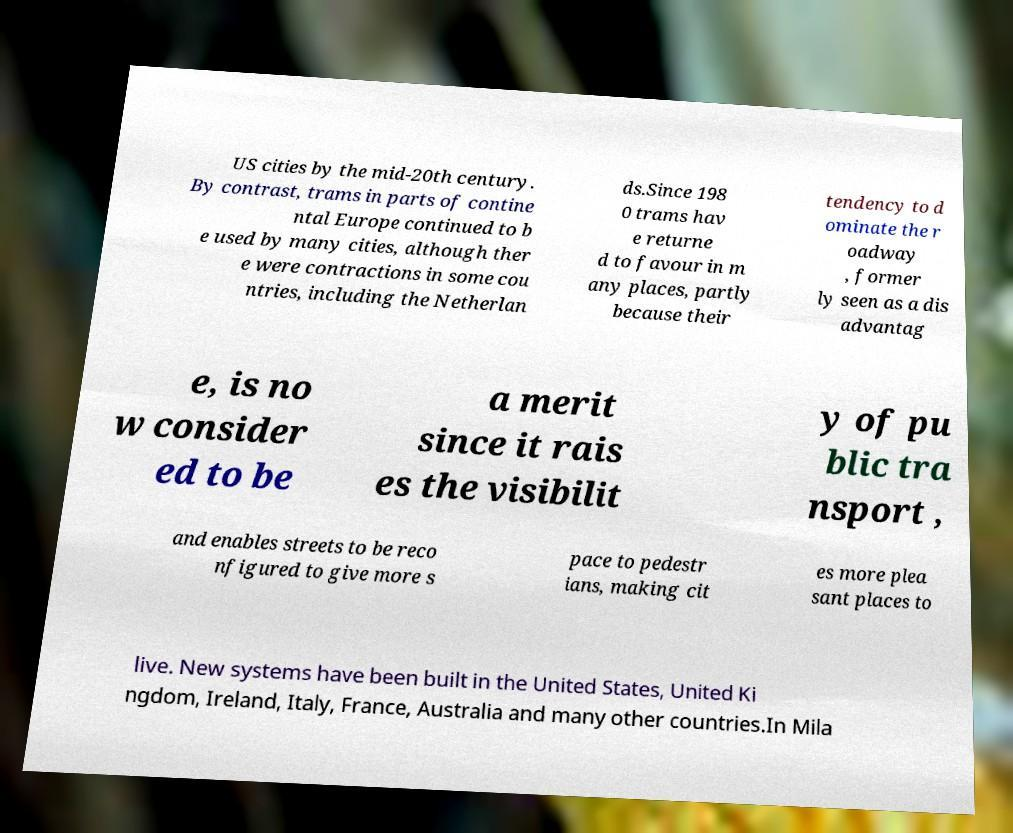Could you assist in decoding the text presented in this image and type it out clearly? US cities by the mid-20th century. By contrast, trams in parts of contine ntal Europe continued to b e used by many cities, although ther e were contractions in some cou ntries, including the Netherlan ds.Since 198 0 trams hav e returne d to favour in m any places, partly because their tendency to d ominate the r oadway , former ly seen as a dis advantag e, is no w consider ed to be a merit since it rais es the visibilit y of pu blic tra nsport , and enables streets to be reco nfigured to give more s pace to pedestr ians, making cit es more plea sant places to live. New systems have been built in the United States, United Ki ngdom, Ireland, Italy, France, Australia and many other countries.In Mila 